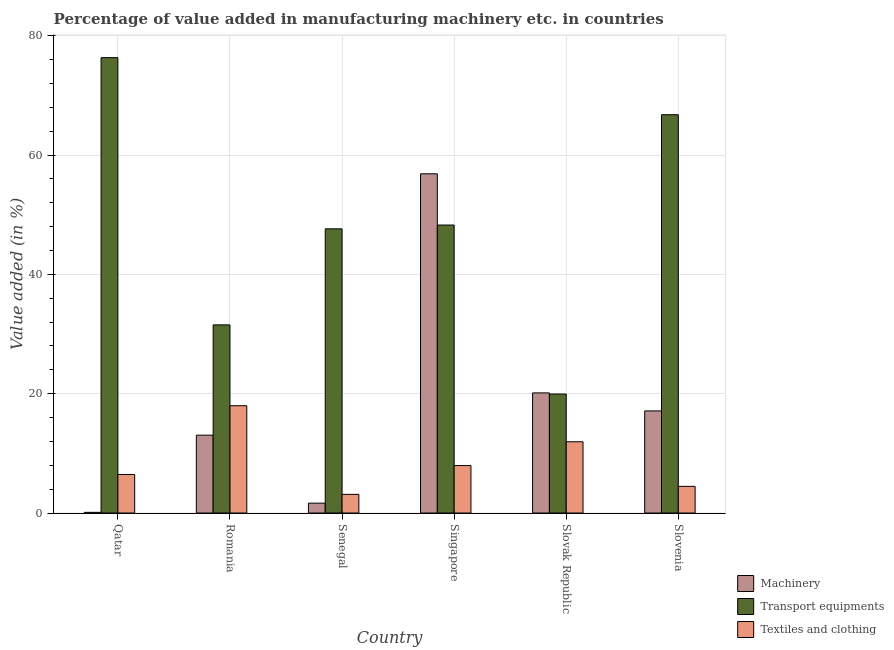How many different coloured bars are there?
Provide a succinct answer. 3. How many groups of bars are there?
Make the answer very short. 6. How many bars are there on the 3rd tick from the right?
Give a very brief answer. 3. What is the label of the 2nd group of bars from the left?
Ensure brevity in your answer.  Romania. In how many cases, is the number of bars for a given country not equal to the number of legend labels?
Offer a very short reply. 0. What is the value added in manufacturing textile and clothing in Slovak Republic?
Keep it short and to the point. 11.94. Across all countries, what is the maximum value added in manufacturing transport equipments?
Provide a succinct answer. 76.33. Across all countries, what is the minimum value added in manufacturing textile and clothing?
Provide a succinct answer. 3.13. In which country was the value added in manufacturing transport equipments maximum?
Your answer should be compact. Qatar. In which country was the value added in manufacturing textile and clothing minimum?
Your answer should be very brief. Senegal. What is the total value added in manufacturing machinery in the graph?
Provide a succinct answer. 108.94. What is the difference between the value added in manufacturing transport equipments in Qatar and that in Slovenia?
Provide a short and direct response. 9.56. What is the difference between the value added in manufacturing machinery in Slovenia and the value added in manufacturing transport equipments in Singapore?
Your answer should be very brief. -31.15. What is the average value added in manufacturing transport equipments per country?
Offer a terse response. 48.41. What is the difference between the value added in manufacturing machinery and value added in manufacturing textile and clothing in Qatar?
Give a very brief answer. -6.35. What is the ratio of the value added in manufacturing machinery in Romania to that in Slovenia?
Ensure brevity in your answer.  0.76. Is the difference between the value added in manufacturing transport equipments in Romania and Senegal greater than the difference between the value added in manufacturing textile and clothing in Romania and Senegal?
Your answer should be very brief. No. What is the difference between the highest and the second highest value added in manufacturing transport equipments?
Your answer should be very brief. 9.56. What is the difference between the highest and the lowest value added in manufacturing machinery?
Make the answer very short. 56.75. In how many countries, is the value added in manufacturing machinery greater than the average value added in manufacturing machinery taken over all countries?
Provide a succinct answer. 2. Is the sum of the value added in manufacturing transport equipments in Qatar and Slovak Republic greater than the maximum value added in manufacturing textile and clothing across all countries?
Provide a short and direct response. Yes. What does the 1st bar from the left in Slovenia represents?
Offer a terse response. Machinery. What does the 1st bar from the right in Slovak Republic represents?
Keep it short and to the point. Textiles and clothing. Is it the case that in every country, the sum of the value added in manufacturing machinery and value added in manufacturing transport equipments is greater than the value added in manufacturing textile and clothing?
Your response must be concise. Yes. How many bars are there?
Your answer should be very brief. 18. Does the graph contain grids?
Provide a short and direct response. Yes. How are the legend labels stacked?
Your answer should be compact. Vertical. What is the title of the graph?
Give a very brief answer. Percentage of value added in manufacturing machinery etc. in countries. What is the label or title of the Y-axis?
Provide a succinct answer. Value added (in %). What is the Value added (in %) in Machinery in Qatar?
Provide a short and direct response. 0.11. What is the Value added (in %) in Transport equipments in Qatar?
Your answer should be compact. 76.33. What is the Value added (in %) of Textiles and clothing in Qatar?
Your answer should be compact. 6.46. What is the Value added (in %) of Machinery in Romania?
Your answer should be compact. 13.05. What is the Value added (in %) of Transport equipments in Romania?
Your response must be concise. 31.54. What is the Value added (in %) in Textiles and clothing in Romania?
Make the answer very short. 17.99. What is the Value added (in %) in Machinery in Senegal?
Provide a succinct answer. 1.66. What is the Value added (in %) of Transport equipments in Senegal?
Offer a very short reply. 47.64. What is the Value added (in %) of Textiles and clothing in Senegal?
Your answer should be very brief. 3.13. What is the Value added (in %) in Machinery in Singapore?
Provide a short and direct response. 56.86. What is the Value added (in %) in Transport equipments in Singapore?
Provide a short and direct response. 48.27. What is the Value added (in %) of Textiles and clothing in Singapore?
Make the answer very short. 7.96. What is the Value added (in %) of Machinery in Slovak Republic?
Your answer should be very brief. 20.14. What is the Value added (in %) in Transport equipments in Slovak Republic?
Offer a very short reply. 19.95. What is the Value added (in %) in Textiles and clothing in Slovak Republic?
Keep it short and to the point. 11.94. What is the Value added (in %) in Machinery in Slovenia?
Your response must be concise. 17.12. What is the Value added (in %) of Transport equipments in Slovenia?
Provide a succinct answer. 66.77. What is the Value added (in %) of Textiles and clothing in Slovenia?
Your answer should be very brief. 4.47. Across all countries, what is the maximum Value added (in %) of Machinery?
Keep it short and to the point. 56.86. Across all countries, what is the maximum Value added (in %) in Transport equipments?
Your response must be concise. 76.33. Across all countries, what is the maximum Value added (in %) of Textiles and clothing?
Provide a succinct answer. 17.99. Across all countries, what is the minimum Value added (in %) in Machinery?
Your response must be concise. 0.11. Across all countries, what is the minimum Value added (in %) in Transport equipments?
Your response must be concise. 19.95. Across all countries, what is the minimum Value added (in %) of Textiles and clothing?
Give a very brief answer. 3.13. What is the total Value added (in %) of Machinery in the graph?
Keep it short and to the point. 108.94. What is the total Value added (in %) of Transport equipments in the graph?
Offer a very short reply. 290.49. What is the total Value added (in %) in Textiles and clothing in the graph?
Keep it short and to the point. 51.94. What is the difference between the Value added (in %) in Machinery in Qatar and that in Romania?
Offer a terse response. -12.94. What is the difference between the Value added (in %) of Transport equipments in Qatar and that in Romania?
Keep it short and to the point. 44.79. What is the difference between the Value added (in %) in Textiles and clothing in Qatar and that in Romania?
Your answer should be compact. -11.52. What is the difference between the Value added (in %) of Machinery in Qatar and that in Senegal?
Your answer should be very brief. -1.54. What is the difference between the Value added (in %) in Transport equipments in Qatar and that in Senegal?
Provide a succinct answer. 28.69. What is the difference between the Value added (in %) of Textiles and clothing in Qatar and that in Senegal?
Give a very brief answer. 3.34. What is the difference between the Value added (in %) of Machinery in Qatar and that in Singapore?
Offer a terse response. -56.74. What is the difference between the Value added (in %) of Transport equipments in Qatar and that in Singapore?
Your answer should be compact. 28.06. What is the difference between the Value added (in %) in Textiles and clothing in Qatar and that in Singapore?
Provide a succinct answer. -1.5. What is the difference between the Value added (in %) in Machinery in Qatar and that in Slovak Republic?
Ensure brevity in your answer.  -20.02. What is the difference between the Value added (in %) of Transport equipments in Qatar and that in Slovak Republic?
Provide a succinct answer. 56.38. What is the difference between the Value added (in %) of Textiles and clothing in Qatar and that in Slovak Republic?
Ensure brevity in your answer.  -5.48. What is the difference between the Value added (in %) in Machinery in Qatar and that in Slovenia?
Provide a short and direct response. -17. What is the difference between the Value added (in %) of Transport equipments in Qatar and that in Slovenia?
Keep it short and to the point. 9.56. What is the difference between the Value added (in %) in Textiles and clothing in Qatar and that in Slovenia?
Provide a succinct answer. 1.99. What is the difference between the Value added (in %) in Machinery in Romania and that in Senegal?
Make the answer very short. 11.4. What is the difference between the Value added (in %) in Transport equipments in Romania and that in Senegal?
Keep it short and to the point. -16.1. What is the difference between the Value added (in %) of Textiles and clothing in Romania and that in Senegal?
Give a very brief answer. 14.86. What is the difference between the Value added (in %) of Machinery in Romania and that in Singapore?
Make the answer very short. -43.81. What is the difference between the Value added (in %) in Transport equipments in Romania and that in Singapore?
Ensure brevity in your answer.  -16.74. What is the difference between the Value added (in %) in Textiles and clothing in Romania and that in Singapore?
Offer a terse response. 10.03. What is the difference between the Value added (in %) in Machinery in Romania and that in Slovak Republic?
Make the answer very short. -7.09. What is the difference between the Value added (in %) of Transport equipments in Romania and that in Slovak Republic?
Make the answer very short. 11.59. What is the difference between the Value added (in %) in Textiles and clothing in Romania and that in Slovak Republic?
Offer a very short reply. 6.04. What is the difference between the Value added (in %) of Machinery in Romania and that in Slovenia?
Your answer should be very brief. -4.07. What is the difference between the Value added (in %) of Transport equipments in Romania and that in Slovenia?
Give a very brief answer. -35.23. What is the difference between the Value added (in %) in Textiles and clothing in Romania and that in Slovenia?
Make the answer very short. 13.52. What is the difference between the Value added (in %) in Machinery in Senegal and that in Singapore?
Your answer should be very brief. -55.2. What is the difference between the Value added (in %) of Transport equipments in Senegal and that in Singapore?
Ensure brevity in your answer.  -0.64. What is the difference between the Value added (in %) of Textiles and clothing in Senegal and that in Singapore?
Keep it short and to the point. -4.83. What is the difference between the Value added (in %) of Machinery in Senegal and that in Slovak Republic?
Make the answer very short. -18.48. What is the difference between the Value added (in %) in Transport equipments in Senegal and that in Slovak Republic?
Offer a very short reply. 27.69. What is the difference between the Value added (in %) of Textiles and clothing in Senegal and that in Slovak Republic?
Your answer should be very brief. -8.82. What is the difference between the Value added (in %) in Machinery in Senegal and that in Slovenia?
Keep it short and to the point. -15.46. What is the difference between the Value added (in %) of Transport equipments in Senegal and that in Slovenia?
Your response must be concise. -19.13. What is the difference between the Value added (in %) in Textiles and clothing in Senegal and that in Slovenia?
Your answer should be very brief. -1.34. What is the difference between the Value added (in %) in Machinery in Singapore and that in Slovak Republic?
Your response must be concise. 36.72. What is the difference between the Value added (in %) of Transport equipments in Singapore and that in Slovak Republic?
Your answer should be very brief. 28.32. What is the difference between the Value added (in %) in Textiles and clothing in Singapore and that in Slovak Republic?
Your answer should be very brief. -3.99. What is the difference between the Value added (in %) in Machinery in Singapore and that in Slovenia?
Offer a very short reply. 39.74. What is the difference between the Value added (in %) in Transport equipments in Singapore and that in Slovenia?
Your answer should be compact. -18.49. What is the difference between the Value added (in %) of Textiles and clothing in Singapore and that in Slovenia?
Provide a succinct answer. 3.49. What is the difference between the Value added (in %) of Machinery in Slovak Republic and that in Slovenia?
Provide a short and direct response. 3.02. What is the difference between the Value added (in %) in Transport equipments in Slovak Republic and that in Slovenia?
Keep it short and to the point. -46.82. What is the difference between the Value added (in %) in Textiles and clothing in Slovak Republic and that in Slovenia?
Ensure brevity in your answer.  7.47. What is the difference between the Value added (in %) of Machinery in Qatar and the Value added (in %) of Transport equipments in Romania?
Give a very brief answer. -31.42. What is the difference between the Value added (in %) of Machinery in Qatar and the Value added (in %) of Textiles and clothing in Romania?
Your answer should be compact. -17.87. What is the difference between the Value added (in %) in Transport equipments in Qatar and the Value added (in %) in Textiles and clothing in Romania?
Offer a terse response. 58.34. What is the difference between the Value added (in %) of Machinery in Qatar and the Value added (in %) of Transport equipments in Senegal?
Make the answer very short. -47.52. What is the difference between the Value added (in %) of Machinery in Qatar and the Value added (in %) of Textiles and clothing in Senegal?
Provide a short and direct response. -3.01. What is the difference between the Value added (in %) in Transport equipments in Qatar and the Value added (in %) in Textiles and clothing in Senegal?
Offer a terse response. 73.2. What is the difference between the Value added (in %) in Machinery in Qatar and the Value added (in %) in Transport equipments in Singapore?
Your answer should be very brief. -48.16. What is the difference between the Value added (in %) of Machinery in Qatar and the Value added (in %) of Textiles and clothing in Singapore?
Give a very brief answer. -7.84. What is the difference between the Value added (in %) of Transport equipments in Qatar and the Value added (in %) of Textiles and clothing in Singapore?
Offer a very short reply. 68.37. What is the difference between the Value added (in %) of Machinery in Qatar and the Value added (in %) of Transport equipments in Slovak Republic?
Ensure brevity in your answer.  -19.83. What is the difference between the Value added (in %) in Machinery in Qatar and the Value added (in %) in Textiles and clothing in Slovak Republic?
Give a very brief answer. -11.83. What is the difference between the Value added (in %) in Transport equipments in Qatar and the Value added (in %) in Textiles and clothing in Slovak Republic?
Your answer should be very brief. 64.39. What is the difference between the Value added (in %) in Machinery in Qatar and the Value added (in %) in Transport equipments in Slovenia?
Offer a very short reply. -66.65. What is the difference between the Value added (in %) of Machinery in Qatar and the Value added (in %) of Textiles and clothing in Slovenia?
Provide a succinct answer. -4.36. What is the difference between the Value added (in %) in Transport equipments in Qatar and the Value added (in %) in Textiles and clothing in Slovenia?
Your answer should be compact. 71.86. What is the difference between the Value added (in %) of Machinery in Romania and the Value added (in %) of Transport equipments in Senegal?
Keep it short and to the point. -34.58. What is the difference between the Value added (in %) of Machinery in Romania and the Value added (in %) of Textiles and clothing in Senegal?
Provide a succinct answer. 9.93. What is the difference between the Value added (in %) of Transport equipments in Romania and the Value added (in %) of Textiles and clothing in Senegal?
Your answer should be compact. 28.41. What is the difference between the Value added (in %) in Machinery in Romania and the Value added (in %) in Transport equipments in Singapore?
Offer a terse response. -35.22. What is the difference between the Value added (in %) in Machinery in Romania and the Value added (in %) in Textiles and clothing in Singapore?
Offer a terse response. 5.09. What is the difference between the Value added (in %) of Transport equipments in Romania and the Value added (in %) of Textiles and clothing in Singapore?
Make the answer very short. 23.58. What is the difference between the Value added (in %) in Machinery in Romania and the Value added (in %) in Transport equipments in Slovak Republic?
Make the answer very short. -6.9. What is the difference between the Value added (in %) in Machinery in Romania and the Value added (in %) in Textiles and clothing in Slovak Republic?
Provide a succinct answer. 1.11. What is the difference between the Value added (in %) of Transport equipments in Romania and the Value added (in %) of Textiles and clothing in Slovak Republic?
Your answer should be compact. 19.59. What is the difference between the Value added (in %) of Machinery in Romania and the Value added (in %) of Transport equipments in Slovenia?
Your answer should be very brief. -53.71. What is the difference between the Value added (in %) of Machinery in Romania and the Value added (in %) of Textiles and clothing in Slovenia?
Keep it short and to the point. 8.58. What is the difference between the Value added (in %) of Transport equipments in Romania and the Value added (in %) of Textiles and clothing in Slovenia?
Provide a succinct answer. 27.07. What is the difference between the Value added (in %) in Machinery in Senegal and the Value added (in %) in Transport equipments in Singapore?
Keep it short and to the point. -46.62. What is the difference between the Value added (in %) in Machinery in Senegal and the Value added (in %) in Textiles and clothing in Singapore?
Provide a succinct answer. -6.3. What is the difference between the Value added (in %) of Transport equipments in Senegal and the Value added (in %) of Textiles and clothing in Singapore?
Provide a short and direct response. 39.68. What is the difference between the Value added (in %) of Machinery in Senegal and the Value added (in %) of Transport equipments in Slovak Republic?
Offer a terse response. -18.29. What is the difference between the Value added (in %) of Machinery in Senegal and the Value added (in %) of Textiles and clothing in Slovak Republic?
Give a very brief answer. -10.29. What is the difference between the Value added (in %) in Transport equipments in Senegal and the Value added (in %) in Textiles and clothing in Slovak Republic?
Your answer should be compact. 35.69. What is the difference between the Value added (in %) in Machinery in Senegal and the Value added (in %) in Transport equipments in Slovenia?
Offer a terse response. -65.11. What is the difference between the Value added (in %) of Machinery in Senegal and the Value added (in %) of Textiles and clothing in Slovenia?
Make the answer very short. -2.81. What is the difference between the Value added (in %) in Transport equipments in Senegal and the Value added (in %) in Textiles and clothing in Slovenia?
Keep it short and to the point. 43.17. What is the difference between the Value added (in %) in Machinery in Singapore and the Value added (in %) in Transport equipments in Slovak Republic?
Your response must be concise. 36.91. What is the difference between the Value added (in %) of Machinery in Singapore and the Value added (in %) of Textiles and clothing in Slovak Republic?
Provide a succinct answer. 44.92. What is the difference between the Value added (in %) of Transport equipments in Singapore and the Value added (in %) of Textiles and clothing in Slovak Republic?
Keep it short and to the point. 36.33. What is the difference between the Value added (in %) in Machinery in Singapore and the Value added (in %) in Transport equipments in Slovenia?
Provide a short and direct response. -9.91. What is the difference between the Value added (in %) of Machinery in Singapore and the Value added (in %) of Textiles and clothing in Slovenia?
Provide a short and direct response. 52.39. What is the difference between the Value added (in %) of Transport equipments in Singapore and the Value added (in %) of Textiles and clothing in Slovenia?
Make the answer very short. 43.8. What is the difference between the Value added (in %) in Machinery in Slovak Republic and the Value added (in %) in Transport equipments in Slovenia?
Your answer should be very brief. -46.63. What is the difference between the Value added (in %) in Machinery in Slovak Republic and the Value added (in %) in Textiles and clothing in Slovenia?
Provide a succinct answer. 15.67. What is the difference between the Value added (in %) in Transport equipments in Slovak Republic and the Value added (in %) in Textiles and clothing in Slovenia?
Provide a succinct answer. 15.48. What is the average Value added (in %) in Machinery per country?
Ensure brevity in your answer.  18.16. What is the average Value added (in %) in Transport equipments per country?
Offer a terse response. 48.41. What is the average Value added (in %) in Textiles and clothing per country?
Make the answer very short. 8.66. What is the difference between the Value added (in %) in Machinery and Value added (in %) in Transport equipments in Qatar?
Make the answer very short. -76.22. What is the difference between the Value added (in %) of Machinery and Value added (in %) of Textiles and clothing in Qatar?
Offer a very short reply. -6.35. What is the difference between the Value added (in %) in Transport equipments and Value added (in %) in Textiles and clothing in Qatar?
Offer a terse response. 69.87. What is the difference between the Value added (in %) in Machinery and Value added (in %) in Transport equipments in Romania?
Keep it short and to the point. -18.48. What is the difference between the Value added (in %) of Machinery and Value added (in %) of Textiles and clothing in Romania?
Provide a succinct answer. -4.93. What is the difference between the Value added (in %) of Transport equipments and Value added (in %) of Textiles and clothing in Romania?
Offer a very short reply. 13.55. What is the difference between the Value added (in %) in Machinery and Value added (in %) in Transport equipments in Senegal?
Offer a terse response. -45.98. What is the difference between the Value added (in %) in Machinery and Value added (in %) in Textiles and clothing in Senegal?
Your answer should be very brief. -1.47. What is the difference between the Value added (in %) in Transport equipments and Value added (in %) in Textiles and clothing in Senegal?
Give a very brief answer. 44.51. What is the difference between the Value added (in %) of Machinery and Value added (in %) of Transport equipments in Singapore?
Provide a succinct answer. 8.59. What is the difference between the Value added (in %) in Machinery and Value added (in %) in Textiles and clothing in Singapore?
Your response must be concise. 48.9. What is the difference between the Value added (in %) in Transport equipments and Value added (in %) in Textiles and clothing in Singapore?
Keep it short and to the point. 40.31. What is the difference between the Value added (in %) in Machinery and Value added (in %) in Transport equipments in Slovak Republic?
Ensure brevity in your answer.  0.19. What is the difference between the Value added (in %) in Machinery and Value added (in %) in Textiles and clothing in Slovak Republic?
Give a very brief answer. 8.19. What is the difference between the Value added (in %) of Transport equipments and Value added (in %) of Textiles and clothing in Slovak Republic?
Your answer should be compact. 8. What is the difference between the Value added (in %) in Machinery and Value added (in %) in Transport equipments in Slovenia?
Give a very brief answer. -49.65. What is the difference between the Value added (in %) of Machinery and Value added (in %) of Textiles and clothing in Slovenia?
Make the answer very short. 12.65. What is the difference between the Value added (in %) in Transport equipments and Value added (in %) in Textiles and clothing in Slovenia?
Keep it short and to the point. 62.3. What is the ratio of the Value added (in %) in Machinery in Qatar to that in Romania?
Keep it short and to the point. 0.01. What is the ratio of the Value added (in %) in Transport equipments in Qatar to that in Romania?
Ensure brevity in your answer.  2.42. What is the ratio of the Value added (in %) in Textiles and clothing in Qatar to that in Romania?
Your answer should be very brief. 0.36. What is the ratio of the Value added (in %) in Machinery in Qatar to that in Senegal?
Offer a terse response. 0.07. What is the ratio of the Value added (in %) of Transport equipments in Qatar to that in Senegal?
Your response must be concise. 1.6. What is the ratio of the Value added (in %) of Textiles and clothing in Qatar to that in Senegal?
Make the answer very short. 2.07. What is the ratio of the Value added (in %) of Machinery in Qatar to that in Singapore?
Give a very brief answer. 0. What is the ratio of the Value added (in %) in Transport equipments in Qatar to that in Singapore?
Make the answer very short. 1.58. What is the ratio of the Value added (in %) in Textiles and clothing in Qatar to that in Singapore?
Your answer should be very brief. 0.81. What is the ratio of the Value added (in %) in Machinery in Qatar to that in Slovak Republic?
Make the answer very short. 0.01. What is the ratio of the Value added (in %) of Transport equipments in Qatar to that in Slovak Republic?
Give a very brief answer. 3.83. What is the ratio of the Value added (in %) in Textiles and clothing in Qatar to that in Slovak Republic?
Provide a short and direct response. 0.54. What is the ratio of the Value added (in %) in Machinery in Qatar to that in Slovenia?
Your response must be concise. 0.01. What is the ratio of the Value added (in %) in Transport equipments in Qatar to that in Slovenia?
Your answer should be very brief. 1.14. What is the ratio of the Value added (in %) of Textiles and clothing in Qatar to that in Slovenia?
Provide a succinct answer. 1.45. What is the ratio of the Value added (in %) in Machinery in Romania to that in Senegal?
Your answer should be very brief. 7.88. What is the ratio of the Value added (in %) in Transport equipments in Romania to that in Senegal?
Keep it short and to the point. 0.66. What is the ratio of the Value added (in %) in Textiles and clothing in Romania to that in Senegal?
Give a very brief answer. 5.75. What is the ratio of the Value added (in %) in Machinery in Romania to that in Singapore?
Offer a terse response. 0.23. What is the ratio of the Value added (in %) in Transport equipments in Romania to that in Singapore?
Your answer should be very brief. 0.65. What is the ratio of the Value added (in %) of Textiles and clothing in Romania to that in Singapore?
Your answer should be very brief. 2.26. What is the ratio of the Value added (in %) in Machinery in Romania to that in Slovak Republic?
Ensure brevity in your answer.  0.65. What is the ratio of the Value added (in %) in Transport equipments in Romania to that in Slovak Republic?
Your answer should be compact. 1.58. What is the ratio of the Value added (in %) of Textiles and clothing in Romania to that in Slovak Republic?
Offer a terse response. 1.51. What is the ratio of the Value added (in %) in Machinery in Romania to that in Slovenia?
Give a very brief answer. 0.76. What is the ratio of the Value added (in %) in Transport equipments in Romania to that in Slovenia?
Ensure brevity in your answer.  0.47. What is the ratio of the Value added (in %) in Textiles and clothing in Romania to that in Slovenia?
Your answer should be very brief. 4.02. What is the ratio of the Value added (in %) in Machinery in Senegal to that in Singapore?
Make the answer very short. 0.03. What is the ratio of the Value added (in %) of Transport equipments in Senegal to that in Singapore?
Give a very brief answer. 0.99. What is the ratio of the Value added (in %) of Textiles and clothing in Senegal to that in Singapore?
Provide a succinct answer. 0.39. What is the ratio of the Value added (in %) in Machinery in Senegal to that in Slovak Republic?
Your answer should be very brief. 0.08. What is the ratio of the Value added (in %) of Transport equipments in Senegal to that in Slovak Republic?
Provide a succinct answer. 2.39. What is the ratio of the Value added (in %) in Textiles and clothing in Senegal to that in Slovak Republic?
Provide a short and direct response. 0.26. What is the ratio of the Value added (in %) of Machinery in Senegal to that in Slovenia?
Make the answer very short. 0.1. What is the ratio of the Value added (in %) in Transport equipments in Senegal to that in Slovenia?
Provide a short and direct response. 0.71. What is the ratio of the Value added (in %) in Textiles and clothing in Senegal to that in Slovenia?
Your answer should be compact. 0.7. What is the ratio of the Value added (in %) of Machinery in Singapore to that in Slovak Republic?
Make the answer very short. 2.82. What is the ratio of the Value added (in %) of Transport equipments in Singapore to that in Slovak Republic?
Provide a succinct answer. 2.42. What is the ratio of the Value added (in %) of Textiles and clothing in Singapore to that in Slovak Republic?
Offer a very short reply. 0.67. What is the ratio of the Value added (in %) of Machinery in Singapore to that in Slovenia?
Your response must be concise. 3.32. What is the ratio of the Value added (in %) in Transport equipments in Singapore to that in Slovenia?
Your answer should be very brief. 0.72. What is the ratio of the Value added (in %) in Textiles and clothing in Singapore to that in Slovenia?
Give a very brief answer. 1.78. What is the ratio of the Value added (in %) in Machinery in Slovak Republic to that in Slovenia?
Ensure brevity in your answer.  1.18. What is the ratio of the Value added (in %) of Transport equipments in Slovak Republic to that in Slovenia?
Ensure brevity in your answer.  0.3. What is the ratio of the Value added (in %) in Textiles and clothing in Slovak Republic to that in Slovenia?
Ensure brevity in your answer.  2.67. What is the difference between the highest and the second highest Value added (in %) in Machinery?
Your answer should be compact. 36.72. What is the difference between the highest and the second highest Value added (in %) of Transport equipments?
Your answer should be compact. 9.56. What is the difference between the highest and the second highest Value added (in %) in Textiles and clothing?
Provide a succinct answer. 6.04. What is the difference between the highest and the lowest Value added (in %) in Machinery?
Make the answer very short. 56.74. What is the difference between the highest and the lowest Value added (in %) of Transport equipments?
Keep it short and to the point. 56.38. What is the difference between the highest and the lowest Value added (in %) in Textiles and clothing?
Offer a terse response. 14.86. 